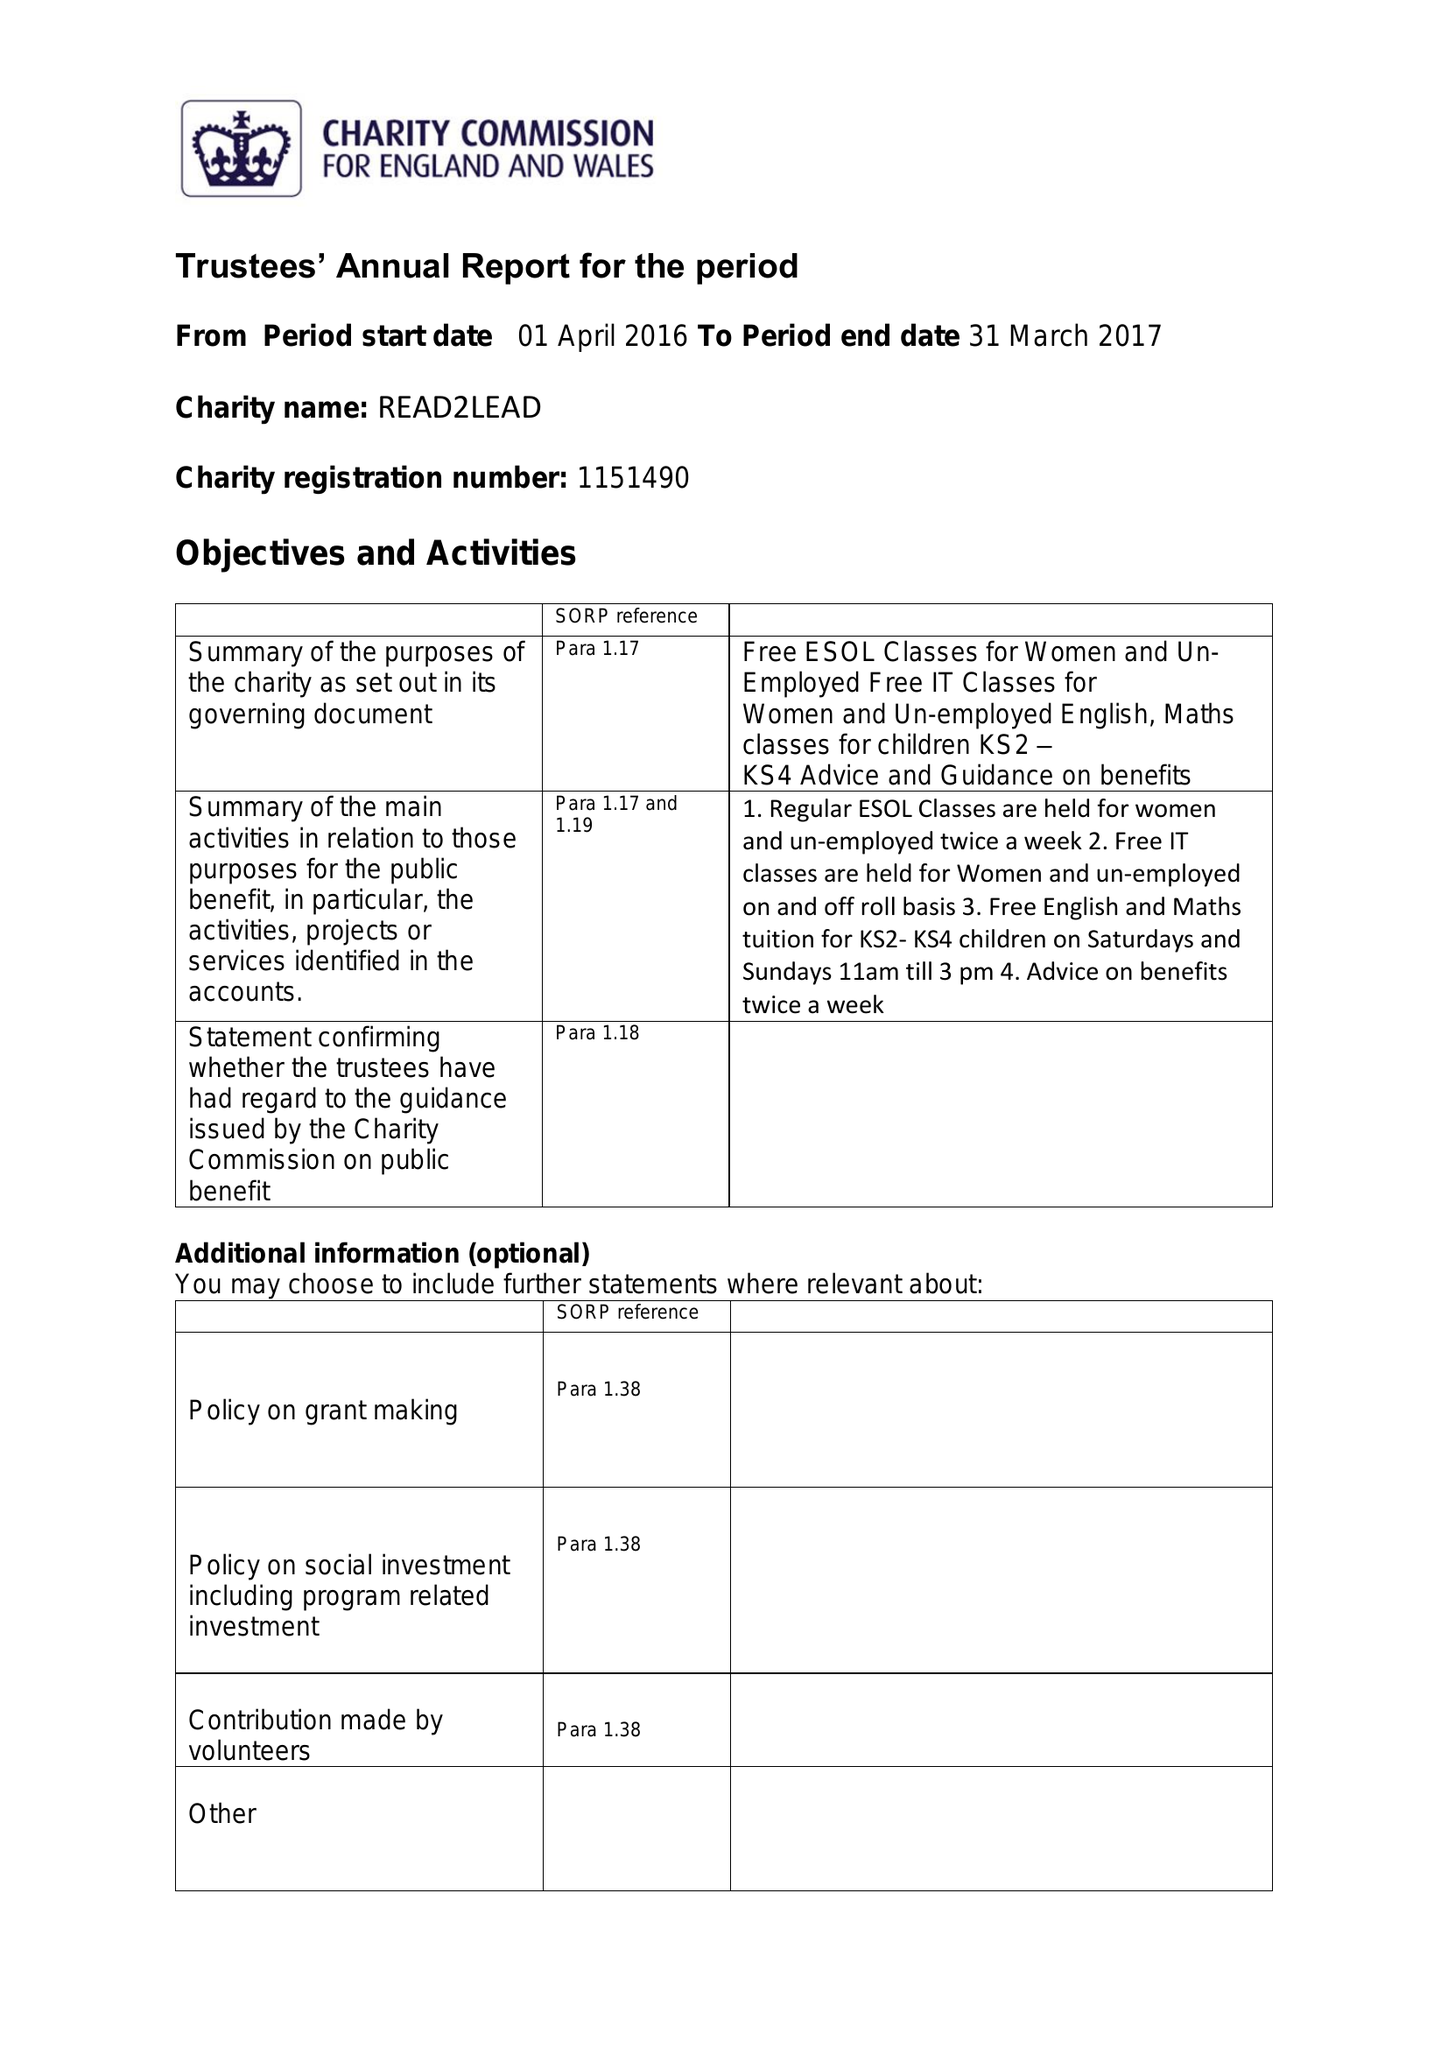What is the value for the address__postcode?
Answer the question using a single word or phrase. B8 1RS 